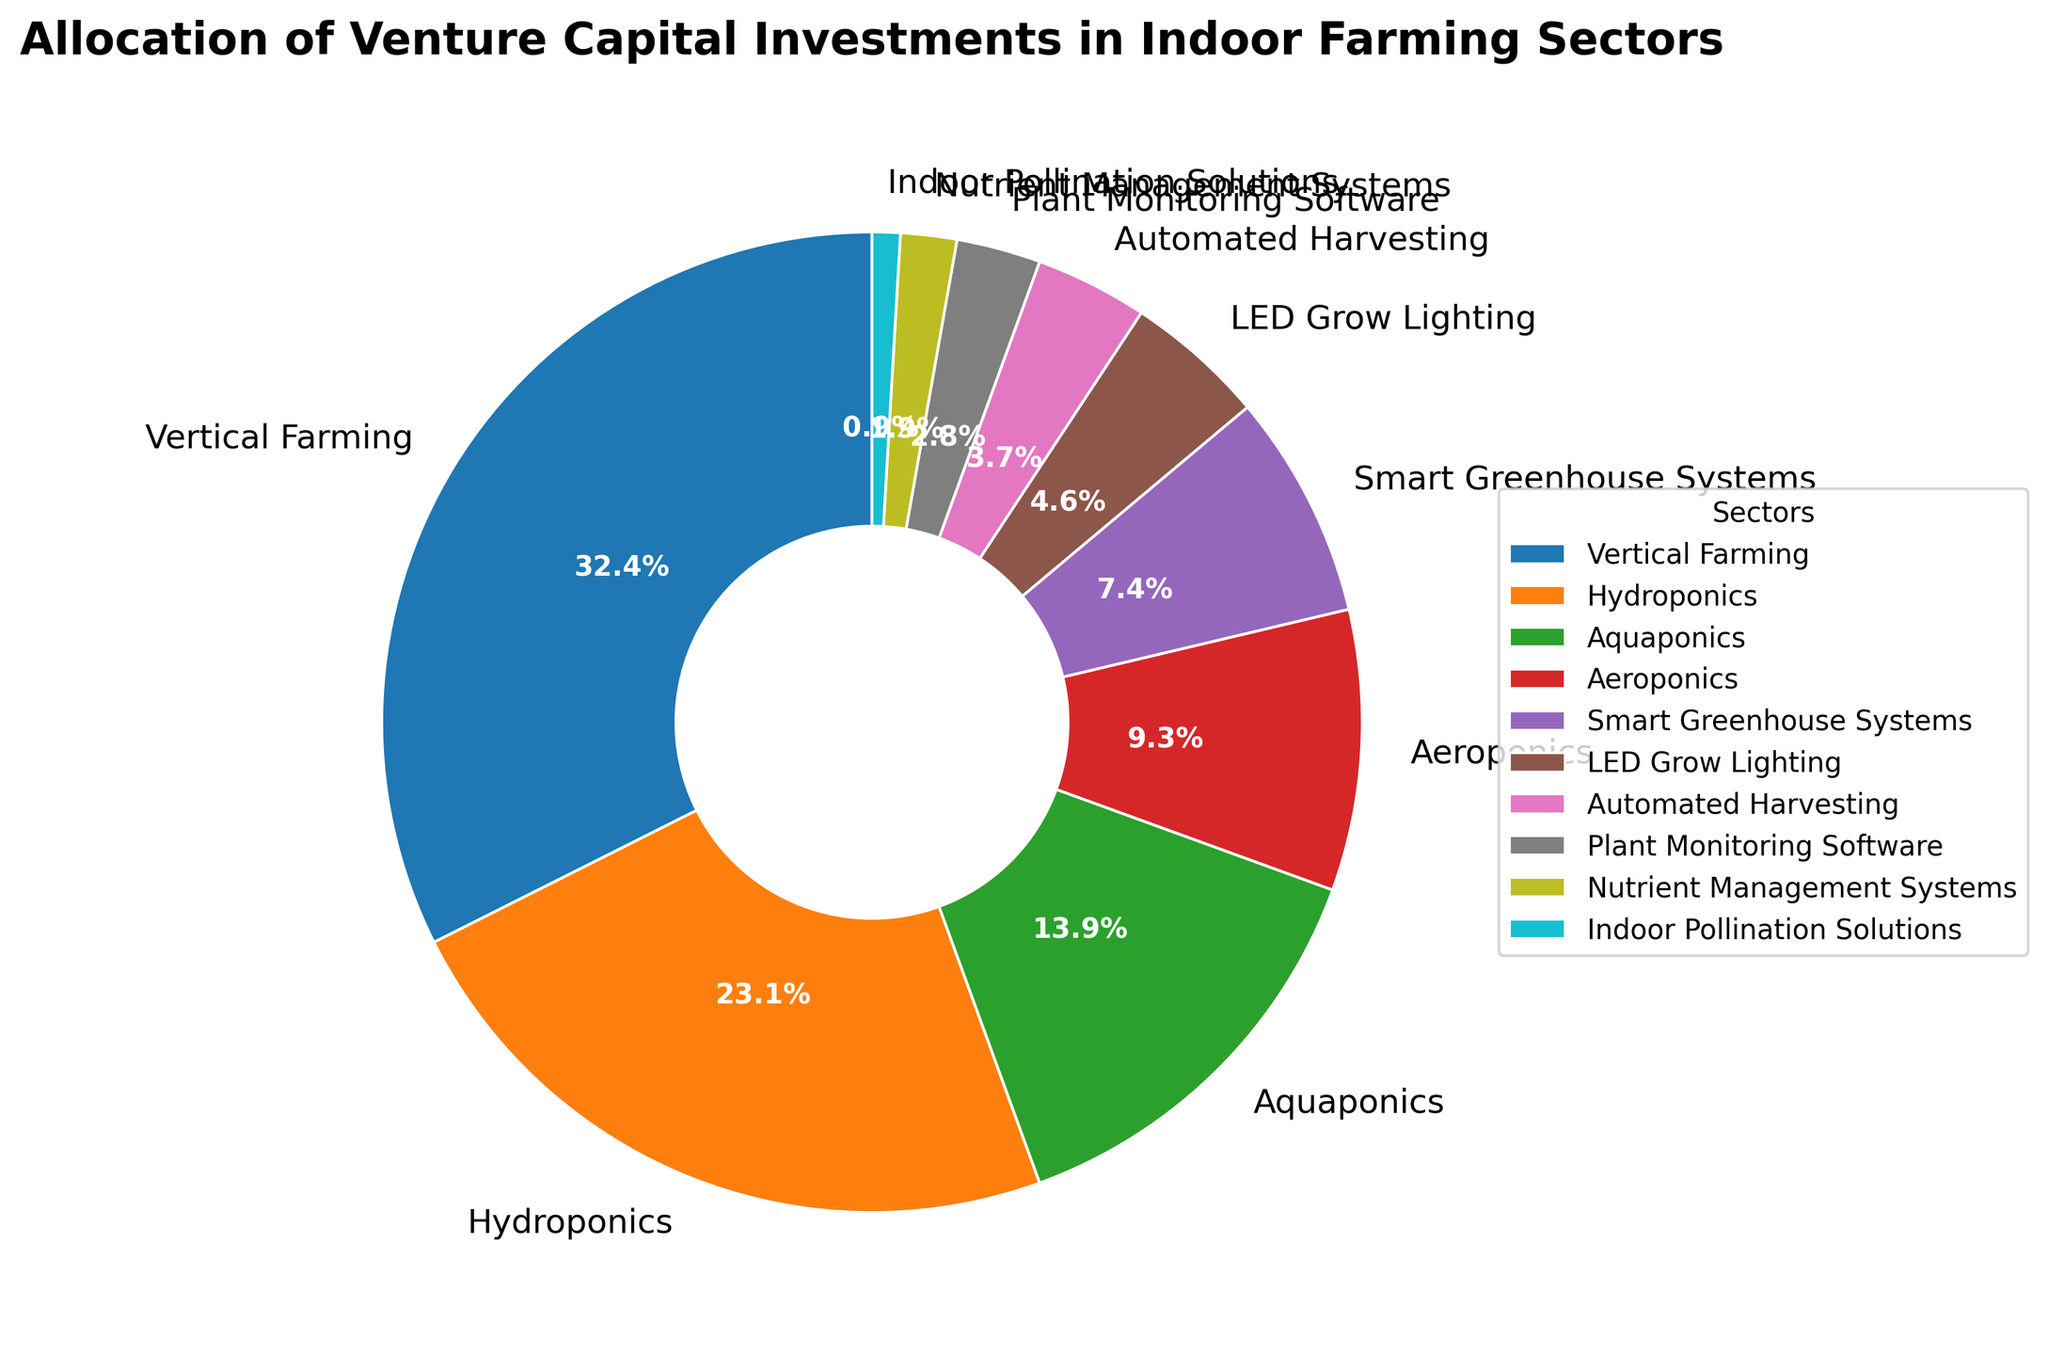What percentage of investments are allocated to Vertical Farming, Hydroponics, and Aeroponics combined? Add the percentages for Vertical Farming (35%), Hydroponics (25%), and Aeroponics (10%). The sum is 35 + 25 + 10 = 70
Answer: 70% Which sector receives the least investment? By observing the smallest slice in the pie chart, Indoor Pollination Solutions receives the least investment at 1%
Answer: Indoor Pollination Solutions How much more investment does Vertical Farming receive compared to Aeroponics? Vertical Farming gets 35% and Aeroponics gets 10%. The difference between them is 35 - 10 = 25
Answer: 25% Which sectors have investments below 5%? By looking at the pie chart, LED Grow Lighting (5%), Automated Harvesting (4%), Plant Monitoring Software (3%), Nutrient Management Systems (2%), and Indoor Pollination Solutions (1%) are below 5%
Answer: LED Grow Lighting, Automated Harvesting, Plant Monitoring Software, Nutrient Management Systems, Indoor Pollination Solutions What is the total percentage of investments allocated to sectors with more than 20%? Sum the percentages of Vertical Farming (35%) and Hydroponics (25%) since they are above 20%. The total is 35 + 25 = 60
Answer: 60% How does the investment in Vertical Farming compare to Hydroponics? The pie chart shows that Vertical Farming has a larger slice at 35% compared to Hydroponics at 25%
Answer: Vertical Farming receives 10% more investment than Hydroponics What percentage of investment is shared by Smart Greenhouse Systems, LED Grow Lighting, and Automated Harvesting combined? Add the percentages for Smart Greenhouse Systems (8%), LED Grow Lighting (5%), and Automated Harvesting (4%). The total is 8 + 5 + 4 = 17
Answer: 17% Which sector has the third highest investment allocation? By looking at the pie chart, the third largest slice is for Aquaponics which receives 15%
Answer: Aquaponics How do the combined investments in Plant Monitoring Software and Nutrient Management Systems compare to Automated Harvesting? Plant Monitoring Software gets 3% and Nutrient Management Systems get 2%. Their combined percentage is 3 + 2 = 5%, which is greater than Automated Harvesting at 4%
Answer: Combined investment in Plant Monitoring Software and Nutrient Management Systems is higher What is the combined percentage of investment in Aquaponics and Smart Greenhouse Systems? Add the percentages for Aquaponics (15%) and Smart Greenhouse Systems (8%). The total is 15 + 8 = 23
Answer: 23% 